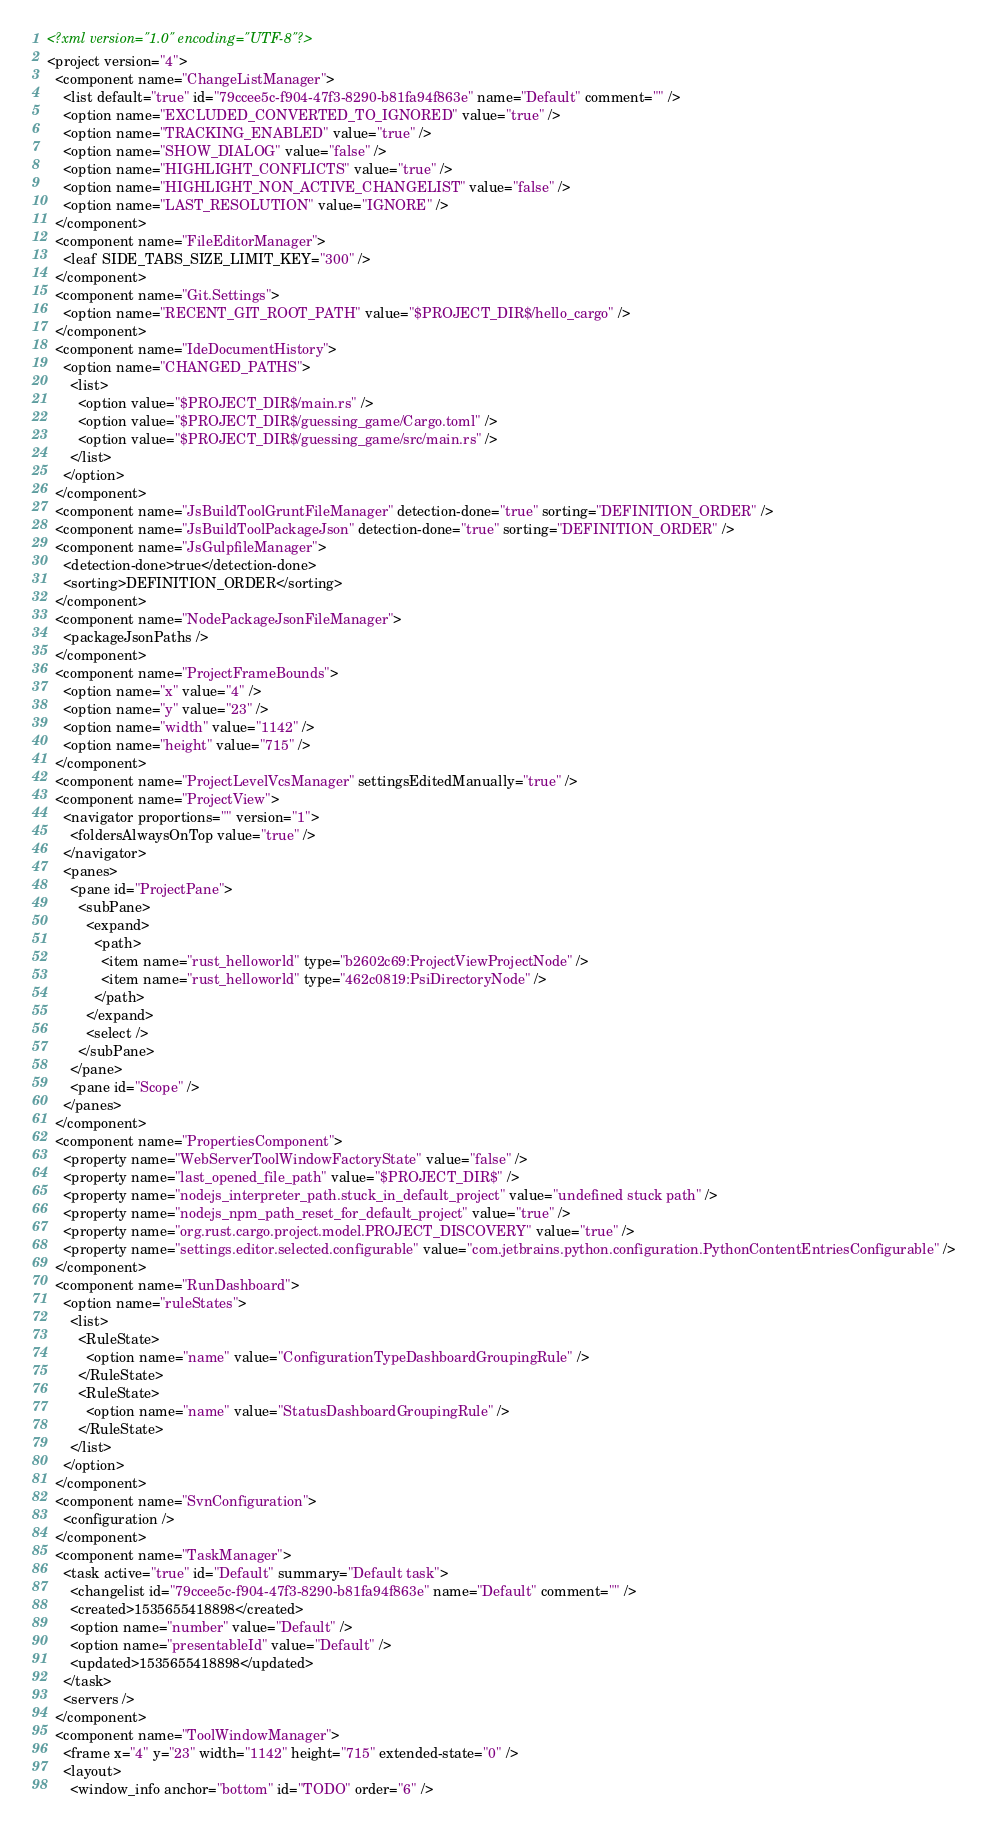<code> <loc_0><loc_0><loc_500><loc_500><_XML_><?xml version="1.0" encoding="UTF-8"?>
<project version="4">
  <component name="ChangeListManager">
    <list default="true" id="79ccee5c-f904-47f3-8290-b81fa94f863e" name="Default" comment="" />
    <option name="EXCLUDED_CONVERTED_TO_IGNORED" value="true" />
    <option name="TRACKING_ENABLED" value="true" />
    <option name="SHOW_DIALOG" value="false" />
    <option name="HIGHLIGHT_CONFLICTS" value="true" />
    <option name="HIGHLIGHT_NON_ACTIVE_CHANGELIST" value="false" />
    <option name="LAST_RESOLUTION" value="IGNORE" />
  </component>
  <component name="FileEditorManager">
    <leaf SIDE_TABS_SIZE_LIMIT_KEY="300" />
  </component>
  <component name="Git.Settings">
    <option name="RECENT_GIT_ROOT_PATH" value="$PROJECT_DIR$/hello_cargo" />
  </component>
  <component name="IdeDocumentHistory">
    <option name="CHANGED_PATHS">
      <list>
        <option value="$PROJECT_DIR$/main.rs" />
        <option value="$PROJECT_DIR$/guessing_game/Cargo.toml" />
        <option value="$PROJECT_DIR$/guessing_game/src/main.rs" />
      </list>
    </option>
  </component>
  <component name="JsBuildToolGruntFileManager" detection-done="true" sorting="DEFINITION_ORDER" />
  <component name="JsBuildToolPackageJson" detection-done="true" sorting="DEFINITION_ORDER" />
  <component name="JsGulpfileManager">
    <detection-done>true</detection-done>
    <sorting>DEFINITION_ORDER</sorting>
  </component>
  <component name="NodePackageJsonFileManager">
    <packageJsonPaths />
  </component>
  <component name="ProjectFrameBounds">
    <option name="x" value="4" />
    <option name="y" value="23" />
    <option name="width" value="1142" />
    <option name="height" value="715" />
  </component>
  <component name="ProjectLevelVcsManager" settingsEditedManually="true" />
  <component name="ProjectView">
    <navigator proportions="" version="1">
      <foldersAlwaysOnTop value="true" />
    </navigator>
    <panes>
      <pane id="ProjectPane">
        <subPane>
          <expand>
            <path>
              <item name="rust_helloworld" type="b2602c69:ProjectViewProjectNode" />
              <item name="rust_helloworld" type="462c0819:PsiDirectoryNode" />
            </path>
          </expand>
          <select />
        </subPane>
      </pane>
      <pane id="Scope" />
    </panes>
  </component>
  <component name="PropertiesComponent">
    <property name="WebServerToolWindowFactoryState" value="false" />
    <property name="last_opened_file_path" value="$PROJECT_DIR$" />
    <property name="nodejs_interpreter_path.stuck_in_default_project" value="undefined stuck path" />
    <property name="nodejs_npm_path_reset_for_default_project" value="true" />
    <property name="org.rust.cargo.project.model.PROJECT_DISCOVERY" value="true" />
    <property name="settings.editor.selected.configurable" value="com.jetbrains.python.configuration.PythonContentEntriesConfigurable" />
  </component>
  <component name="RunDashboard">
    <option name="ruleStates">
      <list>
        <RuleState>
          <option name="name" value="ConfigurationTypeDashboardGroupingRule" />
        </RuleState>
        <RuleState>
          <option name="name" value="StatusDashboardGroupingRule" />
        </RuleState>
      </list>
    </option>
  </component>
  <component name="SvnConfiguration">
    <configuration />
  </component>
  <component name="TaskManager">
    <task active="true" id="Default" summary="Default task">
      <changelist id="79ccee5c-f904-47f3-8290-b81fa94f863e" name="Default" comment="" />
      <created>1535655418898</created>
      <option name="number" value="Default" />
      <option name="presentableId" value="Default" />
      <updated>1535655418898</updated>
    </task>
    <servers />
  </component>
  <component name="ToolWindowManager">
    <frame x="4" y="23" width="1142" height="715" extended-state="0" />
    <layout>
      <window_info anchor="bottom" id="TODO" order="6" /></code> 